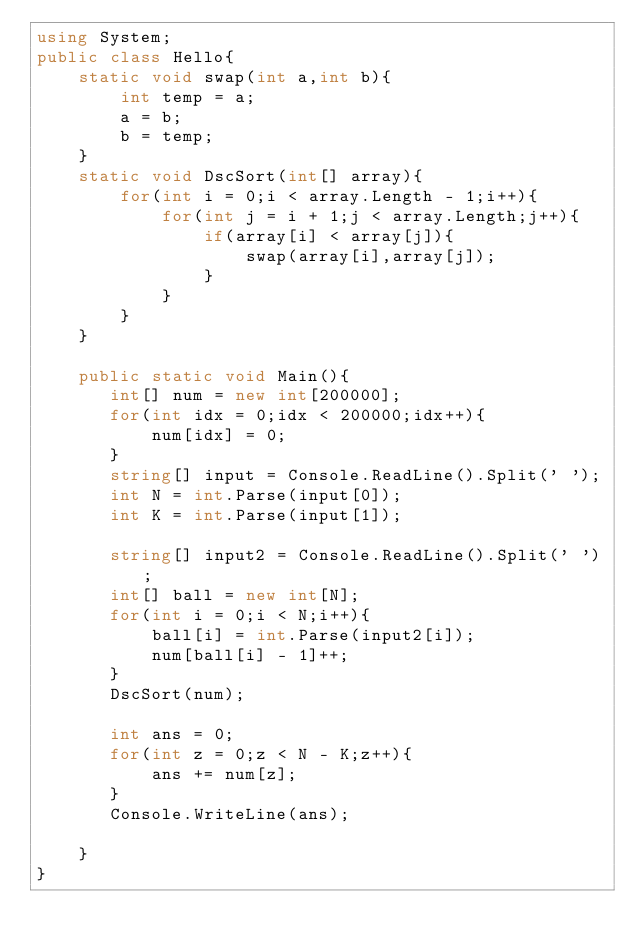<code> <loc_0><loc_0><loc_500><loc_500><_C#_>using System;
public class Hello{
    static void swap(int a,int b){
        int temp = a;
        a = b;
        b = temp;
    }
    static void DscSort(int[] array){
        for(int i = 0;i < array.Length - 1;i++){
            for(int j = i + 1;j < array.Length;j++){
                if(array[i] < array[j]){
                    swap(array[i],array[j]);
                }
            }
        }
    }
    
    public static void Main(){
       int[] num = new int[200000];
       for(int idx = 0;idx < 200000;idx++){
           num[idx] = 0;
       }
       string[] input = Console.ReadLine().Split(' ');
       int N = int.Parse(input[0]);
       int K = int.Parse(input[1]);
       
       string[] input2 = Console.ReadLine().Split(' ');
       int[] ball = new int[N];
       for(int i = 0;i < N;i++){
           ball[i] = int.Parse(input2[i]);
           num[ball[i] - 1]++;
       }
       DscSort(num);
       
       int ans = 0;
       for(int z = 0;z < N - K;z++){
           ans += num[z];
       }
       Console.WriteLine(ans);
       
    }
}
</code> 